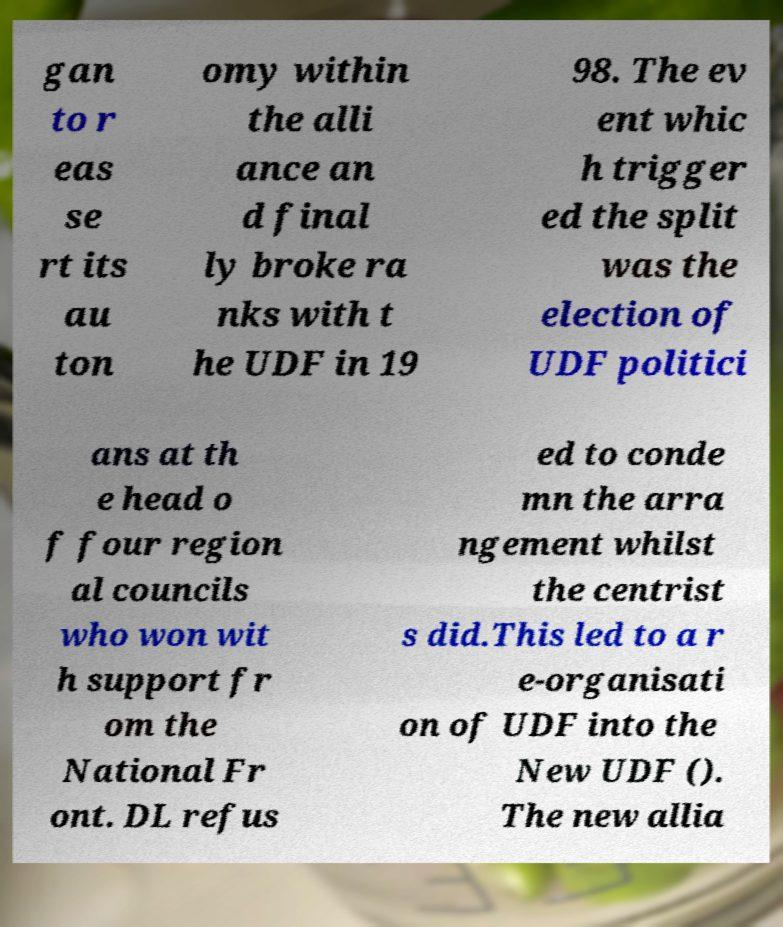Could you extract and type out the text from this image? gan to r eas se rt its au ton omy within the alli ance an d final ly broke ra nks with t he UDF in 19 98. The ev ent whic h trigger ed the split was the election of UDF politici ans at th e head o f four region al councils who won wit h support fr om the National Fr ont. DL refus ed to conde mn the arra ngement whilst the centrist s did.This led to a r e-organisati on of UDF into the New UDF (). The new allia 